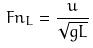Convert formula to latex. <formula><loc_0><loc_0><loc_500><loc_500>F n _ { L } = \frac { u } { \sqrt { g L } }</formula> 